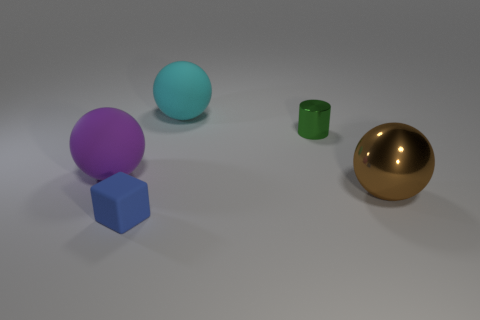Is the number of metal balls that are on the left side of the large purple sphere less than the number of large brown metal balls that are behind the tiny block?
Offer a terse response. Yes. What number of other things are there of the same size as the cylinder?
Keep it short and to the point. 1. Is the brown sphere made of the same material as the tiny thing that is behind the purple rubber thing?
Your answer should be compact. Yes. What number of things are big things that are behind the cylinder or metallic spheres that are on the right side of the metal cylinder?
Offer a terse response. 2. What color is the rubber cube?
Your answer should be compact. Blue. Is the number of shiny things in front of the small blue rubber thing less than the number of purple spheres?
Your response must be concise. Yes. Are there any other things that have the same shape as the blue matte object?
Offer a very short reply. No. Are any tiny matte things visible?
Offer a terse response. Yes. Are there fewer large purple objects than red matte objects?
Ensure brevity in your answer.  No. How many blue blocks are the same material as the big cyan object?
Ensure brevity in your answer.  1. 